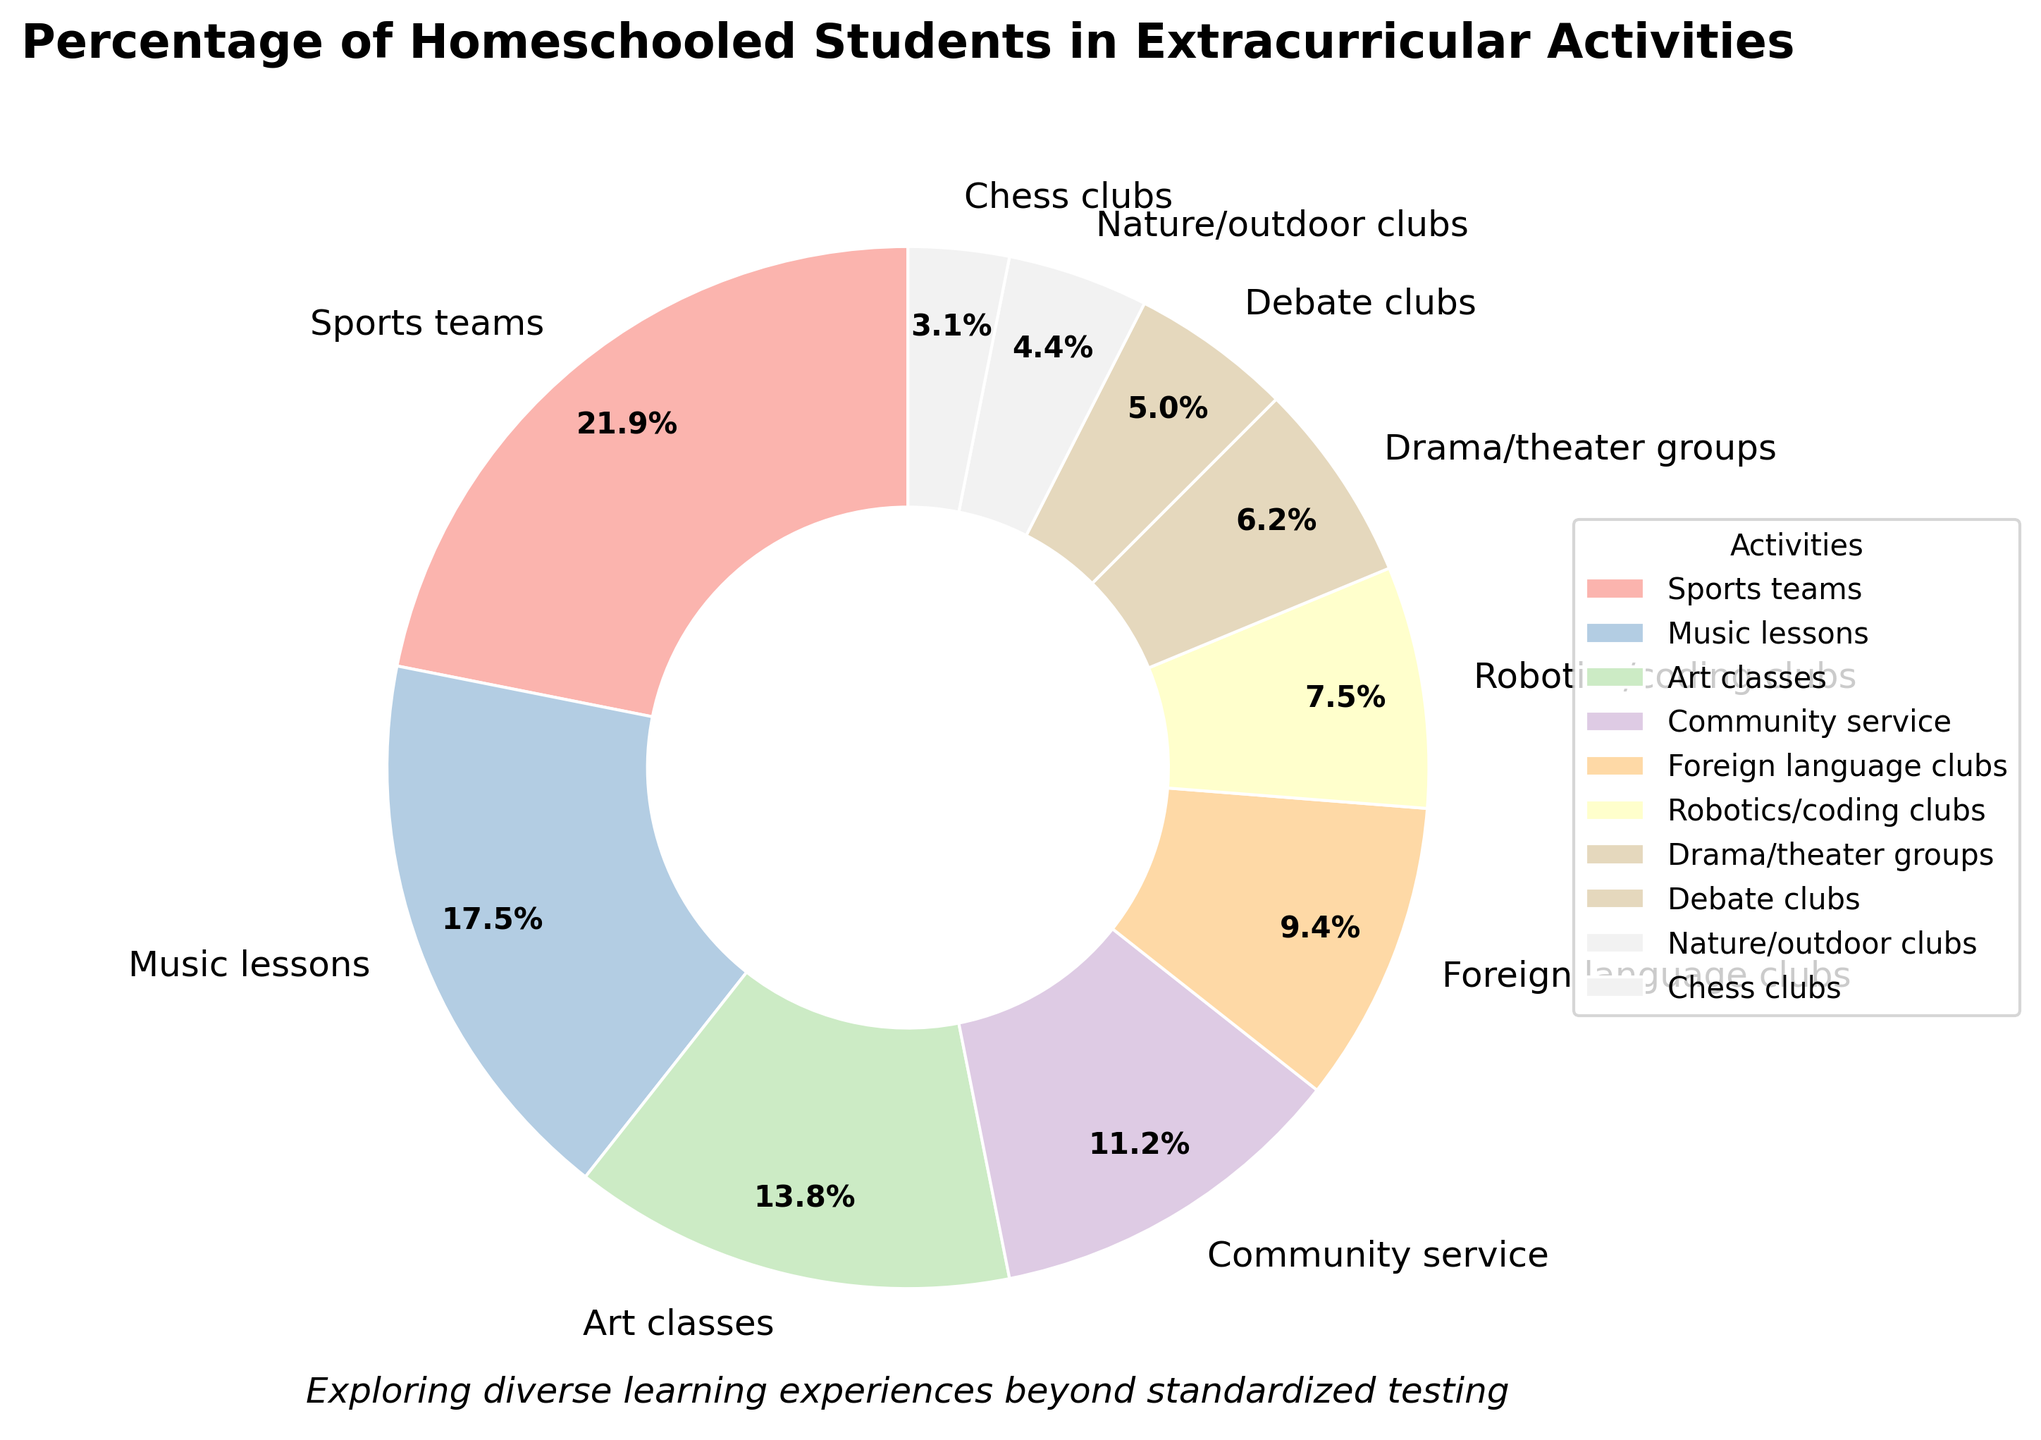Which extracurricular activity has the highest participation rate among homeschooled students? The pie chart shows that 'Sports teams' has the largest wedge, meaning it has the highest percentage.
Answer: Sports teams What is the combined percentage of students participating in Art classes and Music lessons? According to the chart, Art classes have 22% and Music lessons have 28%. Adding these together gives 22% + 28% = 50%.
Answer: 50% How does participation in Foreign language clubs compare to Robotics/coding clubs? The chart shows that Foreign language clubs have 15% while Robotics/coding clubs have 12%. Since 15% is greater than 12%, more students participate in Foreign language clubs.
Answer: Foreign language clubs have a higher participation rate Which three activities have the lowest participation rates? By examining the smallest wedges in the pie chart, we see that Chess clubs (5%), Nature/outdoor clubs (7%), and Debate clubs (8%) have the lowest participation rates.
Answer: Chess clubs, Nature/outdoor clubs, Debate clubs What percentage of students participate in both Drama/theater groups and Debate clubs? The chart shows Drama/theater groups have 10% participation and Debate clubs have 8%. Adding these together gives 10% + 8% = 18%.
Answer: 18% Is participation in Music lessons higher or lower than Community service? The pie chart indicates Music lessons at 28% and Community service at 18%. Since 28% is higher than 18%, participation in Music lessons is higher.
Answer: Higher What is the total percentage of students who participate in either Nature/outdoor clubs or Drama/theater groups or both? The chart shows Nature/outdoor clubs have 7% and Drama/theater groups have 10%. Adding these together gives 7% + 10% = 17%.
Answer: 17% Which activities have a participation rate less than 10%? Examining the wedges, Nature/outdoor clubs (7%), Chess clubs (5%), and Debate clubs (8%) all have less than 10% participation.
Answer: Nature/outdoor clubs, Chess clubs, Debate clubs Is the participation in Community service more than the combined participation in Robotics/coding clubs and Chess clubs? The chart indicates Community service has 18%, while Robotics/coding clubs have 12% and Chess clubs have 5%. Their combined participation is 12% + 5% = 17%, which is less than 18%.
Answer: Yes What is the difference in participation rates between Sports teams and Art classes? The pie chart shows Sports teams at 35% and Art classes at 22%. The difference is calculated by 35% - 22% = 13%.
Answer: 13% 